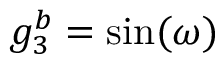<formula> <loc_0><loc_0><loc_500><loc_500>g _ { 3 } ^ { b } = \sin ( \omega )</formula> 